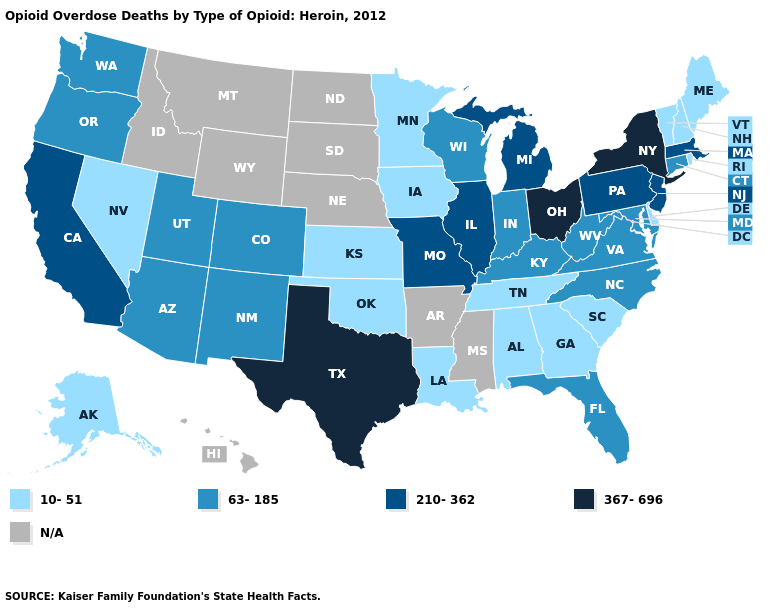Does New York have the highest value in the Northeast?
Keep it brief. Yes. What is the lowest value in the USA?
Give a very brief answer. 10-51. Which states hav the highest value in the South?
Concise answer only. Texas. What is the lowest value in the South?
Write a very short answer. 10-51. Name the states that have a value in the range 210-362?
Answer briefly. California, Illinois, Massachusetts, Michigan, Missouri, New Jersey, Pennsylvania. Name the states that have a value in the range N/A?
Concise answer only. Arkansas, Hawaii, Idaho, Mississippi, Montana, Nebraska, North Dakota, South Dakota, Wyoming. Which states hav the highest value in the MidWest?
Short answer required. Ohio. What is the lowest value in states that border Georgia?
Write a very short answer. 10-51. What is the value of Hawaii?
Write a very short answer. N/A. What is the highest value in the West ?
Be succinct. 210-362. Name the states that have a value in the range 367-696?
Write a very short answer. New York, Ohio, Texas. What is the value of Georgia?
Be succinct. 10-51. Name the states that have a value in the range 10-51?
Give a very brief answer. Alabama, Alaska, Delaware, Georgia, Iowa, Kansas, Louisiana, Maine, Minnesota, Nevada, New Hampshire, Oklahoma, Rhode Island, South Carolina, Tennessee, Vermont. 